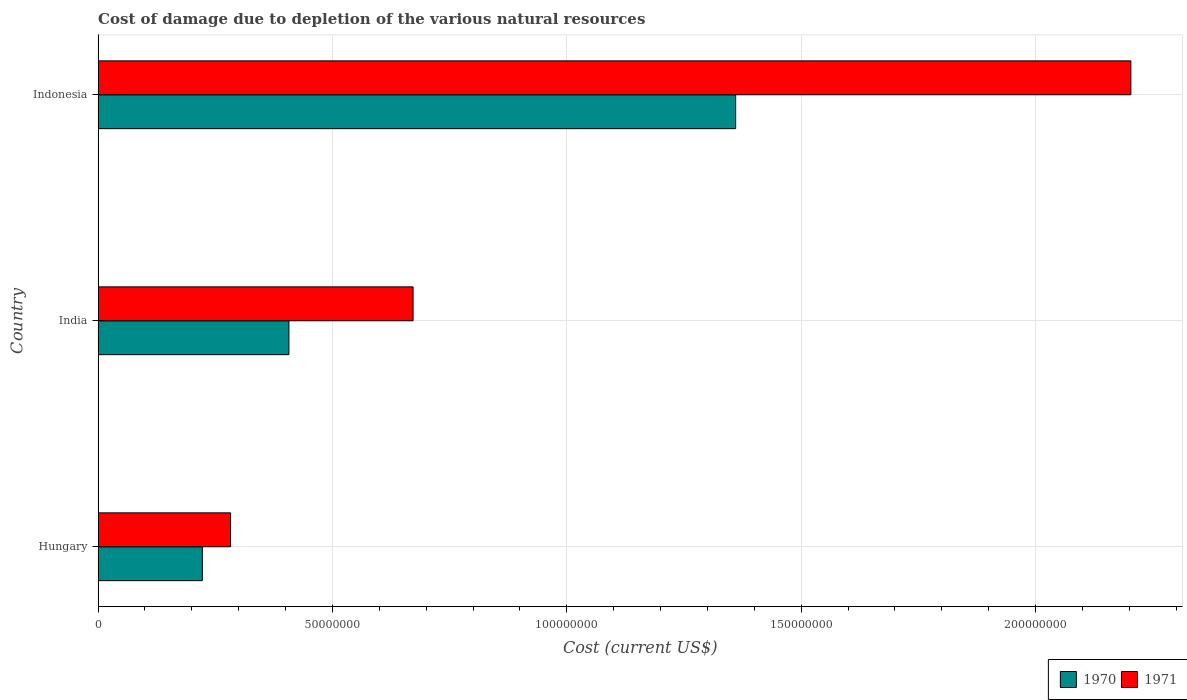How many different coloured bars are there?
Your answer should be compact. 2. Are the number of bars on each tick of the Y-axis equal?
Your response must be concise. Yes. How many bars are there on the 1st tick from the bottom?
Your answer should be compact. 2. In how many cases, is the number of bars for a given country not equal to the number of legend labels?
Offer a very short reply. 0. What is the cost of damage caused due to the depletion of various natural resources in 1970 in Indonesia?
Your response must be concise. 1.36e+08. Across all countries, what is the maximum cost of damage caused due to the depletion of various natural resources in 1970?
Make the answer very short. 1.36e+08. Across all countries, what is the minimum cost of damage caused due to the depletion of various natural resources in 1970?
Ensure brevity in your answer.  2.22e+07. In which country was the cost of damage caused due to the depletion of various natural resources in 1970 maximum?
Keep it short and to the point. Indonesia. In which country was the cost of damage caused due to the depletion of various natural resources in 1970 minimum?
Keep it short and to the point. Hungary. What is the total cost of damage caused due to the depletion of various natural resources in 1971 in the graph?
Give a very brief answer. 3.16e+08. What is the difference between the cost of damage caused due to the depletion of various natural resources in 1971 in India and that in Indonesia?
Your answer should be compact. -1.53e+08. What is the difference between the cost of damage caused due to the depletion of various natural resources in 1971 in India and the cost of damage caused due to the depletion of various natural resources in 1970 in Hungary?
Offer a very short reply. 4.50e+07. What is the average cost of damage caused due to the depletion of various natural resources in 1970 per country?
Make the answer very short. 6.63e+07. What is the difference between the cost of damage caused due to the depletion of various natural resources in 1970 and cost of damage caused due to the depletion of various natural resources in 1971 in Indonesia?
Ensure brevity in your answer.  -8.43e+07. In how many countries, is the cost of damage caused due to the depletion of various natural resources in 1971 greater than 40000000 US$?
Keep it short and to the point. 2. What is the ratio of the cost of damage caused due to the depletion of various natural resources in 1971 in Hungary to that in Indonesia?
Make the answer very short. 0.13. What is the difference between the highest and the second highest cost of damage caused due to the depletion of various natural resources in 1970?
Your answer should be compact. 9.53e+07. What is the difference between the highest and the lowest cost of damage caused due to the depletion of various natural resources in 1971?
Offer a very short reply. 1.92e+08. In how many countries, is the cost of damage caused due to the depletion of various natural resources in 1971 greater than the average cost of damage caused due to the depletion of various natural resources in 1971 taken over all countries?
Make the answer very short. 1. What does the 1st bar from the top in Hungary represents?
Your response must be concise. 1971. What does the 1st bar from the bottom in Hungary represents?
Your answer should be compact. 1970. Are all the bars in the graph horizontal?
Offer a terse response. Yes. How many countries are there in the graph?
Offer a very short reply. 3. What is the title of the graph?
Your answer should be very brief. Cost of damage due to depletion of the various natural resources. What is the label or title of the X-axis?
Offer a very short reply. Cost (current US$). What is the Cost (current US$) of 1970 in Hungary?
Your answer should be very brief. 2.22e+07. What is the Cost (current US$) of 1971 in Hungary?
Your answer should be very brief. 2.83e+07. What is the Cost (current US$) of 1970 in India?
Your answer should be very brief. 4.07e+07. What is the Cost (current US$) in 1971 in India?
Your answer should be compact. 6.72e+07. What is the Cost (current US$) in 1970 in Indonesia?
Provide a succinct answer. 1.36e+08. What is the Cost (current US$) in 1971 in Indonesia?
Your answer should be very brief. 2.20e+08. Across all countries, what is the maximum Cost (current US$) of 1970?
Offer a very short reply. 1.36e+08. Across all countries, what is the maximum Cost (current US$) of 1971?
Provide a short and direct response. 2.20e+08. Across all countries, what is the minimum Cost (current US$) of 1970?
Your answer should be very brief. 2.22e+07. Across all countries, what is the minimum Cost (current US$) in 1971?
Your response must be concise. 2.83e+07. What is the total Cost (current US$) in 1970 in the graph?
Your answer should be compact. 1.99e+08. What is the total Cost (current US$) of 1971 in the graph?
Ensure brevity in your answer.  3.16e+08. What is the difference between the Cost (current US$) in 1970 in Hungary and that in India?
Ensure brevity in your answer.  -1.85e+07. What is the difference between the Cost (current US$) of 1971 in Hungary and that in India?
Make the answer very short. -3.89e+07. What is the difference between the Cost (current US$) in 1970 in Hungary and that in Indonesia?
Give a very brief answer. -1.14e+08. What is the difference between the Cost (current US$) in 1971 in Hungary and that in Indonesia?
Your answer should be compact. -1.92e+08. What is the difference between the Cost (current US$) in 1970 in India and that in Indonesia?
Provide a short and direct response. -9.53e+07. What is the difference between the Cost (current US$) in 1971 in India and that in Indonesia?
Your answer should be very brief. -1.53e+08. What is the difference between the Cost (current US$) of 1970 in Hungary and the Cost (current US$) of 1971 in India?
Your answer should be compact. -4.50e+07. What is the difference between the Cost (current US$) of 1970 in Hungary and the Cost (current US$) of 1971 in Indonesia?
Give a very brief answer. -1.98e+08. What is the difference between the Cost (current US$) of 1970 in India and the Cost (current US$) of 1971 in Indonesia?
Give a very brief answer. -1.80e+08. What is the average Cost (current US$) of 1970 per country?
Your answer should be very brief. 6.63e+07. What is the average Cost (current US$) of 1971 per country?
Your answer should be compact. 1.05e+08. What is the difference between the Cost (current US$) in 1970 and Cost (current US$) in 1971 in Hungary?
Keep it short and to the point. -6.02e+06. What is the difference between the Cost (current US$) of 1970 and Cost (current US$) of 1971 in India?
Keep it short and to the point. -2.65e+07. What is the difference between the Cost (current US$) in 1970 and Cost (current US$) in 1971 in Indonesia?
Offer a terse response. -8.43e+07. What is the ratio of the Cost (current US$) of 1970 in Hungary to that in India?
Keep it short and to the point. 0.55. What is the ratio of the Cost (current US$) in 1971 in Hungary to that in India?
Give a very brief answer. 0.42. What is the ratio of the Cost (current US$) in 1970 in Hungary to that in Indonesia?
Offer a terse response. 0.16. What is the ratio of the Cost (current US$) of 1971 in Hungary to that in Indonesia?
Offer a very short reply. 0.13. What is the ratio of the Cost (current US$) of 1970 in India to that in Indonesia?
Keep it short and to the point. 0.3. What is the ratio of the Cost (current US$) in 1971 in India to that in Indonesia?
Your answer should be very brief. 0.3. What is the difference between the highest and the second highest Cost (current US$) of 1970?
Provide a succinct answer. 9.53e+07. What is the difference between the highest and the second highest Cost (current US$) in 1971?
Your answer should be compact. 1.53e+08. What is the difference between the highest and the lowest Cost (current US$) in 1970?
Your response must be concise. 1.14e+08. What is the difference between the highest and the lowest Cost (current US$) of 1971?
Keep it short and to the point. 1.92e+08. 